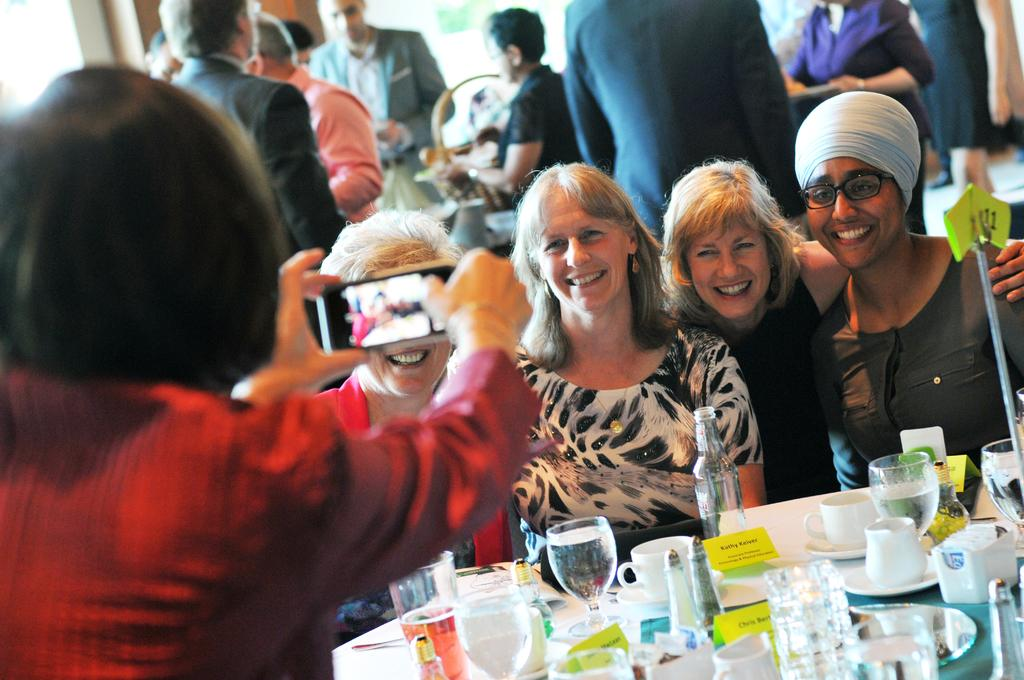How many people can be seen in the image? There are people in the image, but the exact number is not specified. What is a person holding in the image? A person is holding a mobile in the image. What type of objects can be seen on the table? There are glasses, a bottle, cups, saucers, and a stick on the table in the image. Can you describe the background of the image? The background of the image is blurry. What type of vest is being worn by the person holding the rifle in the image? There is no person holding a rifle in the image, and therefore no vest can be observed. 